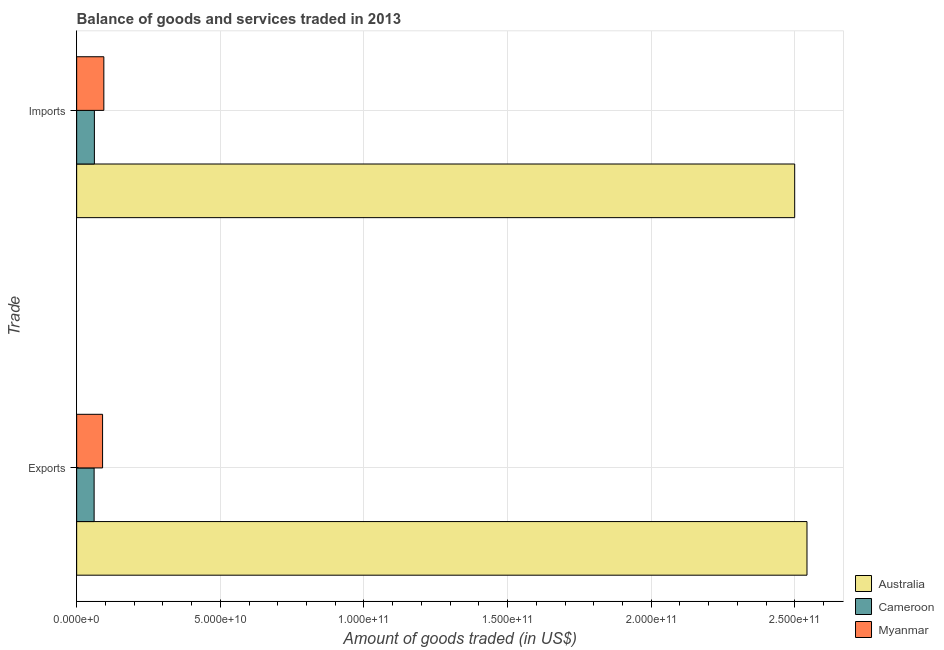How many different coloured bars are there?
Make the answer very short. 3. Are the number of bars per tick equal to the number of legend labels?
Offer a very short reply. Yes. How many bars are there on the 1st tick from the top?
Offer a terse response. 3. How many bars are there on the 2nd tick from the bottom?
Offer a terse response. 3. What is the label of the 2nd group of bars from the top?
Your answer should be compact. Exports. What is the amount of goods imported in Australia?
Give a very brief answer. 2.50e+11. Across all countries, what is the maximum amount of goods imported?
Offer a terse response. 2.50e+11. Across all countries, what is the minimum amount of goods exported?
Make the answer very short. 6.08e+09. In which country was the amount of goods exported minimum?
Your answer should be very brief. Cameroon. What is the total amount of goods exported in the graph?
Provide a succinct answer. 2.69e+11. What is the difference between the amount of goods exported in Myanmar and that in Australia?
Provide a succinct answer. -2.45e+11. What is the difference between the amount of goods imported in Australia and the amount of goods exported in Myanmar?
Make the answer very short. 2.41e+11. What is the average amount of goods imported per country?
Make the answer very short. 8.85e+1. What is the difference between the amount of goods exported and amount of goods imported in Myanmar?
Make the answer very short. -4.40e+08. In how many countries, is the amount of goods exported greater than 130000000000 US$?
Ensure brevity in your answer.  1. What is the ratio of the amount of goods exported in Cameroon to that in Australia?
Your answer should be compact. 0.02. In how many countries, is the amount of goods imported greater than the average amount of goods imported taken over all countries?
Give a very brief answer. 1. What does the 1st bar from the top in Exports represents?
Your answer should be compact. Myanmar. How many countries are there in the graph?
Offer a terse response. 3. Are the values on the major ticks of X-axis written in scientific E-notation?
Make the answer very short. Yes. Where does the legend appear in the graph?
Ensure brevity in your answer.  Bottom right. How are the legend labels stacked?
Provide a short and direct response. Vertical. What is the title of the graph?
Your answer should be very brief. Balance of goods and services traded in 2013. Does "Grenada" appear as one of the legend labels in the graph?
Your answer should be compact. No. What is the label or title of the X-axis?
Provide a succinct answer. Amount of goods traded (in US$). What is the label or title of the Y-axis?
Provide a succinct answer. Trade. What is the Amount of goods traded (in US$) of Australia in Exports?
Make the answer very short. 2.54e+11. What is the Amount of goods traded (in US$) of Cameroon in Exports?
Give a very brief answer. 6.08e+09. What is the Amount of goods traded (in US$) in Myanmar in Exports?
Provide a succinct answer. 9.02e+09. What is the Amount of goods traded (in US$) in Australia in Imports?
Provide a succinct answer. 2.50e+11. What is the Amount of goods traded (in US$) of Cameroon in Imports?
Offer a terse response. 6.17e+09. What is the Amount of goods traded (in US$) of Myanmar in Imports?
Offer a terse response. 9.46e+09. Across all Trade, what is the maximum Amount of goods traded (in US$) in Australia?
Offer a very short reply. 2.54e+11. Across all Trade, what is the maximum Amount of goods traded (in US$) in Cameroon?
Your answer should be very brief. 6.17e+09. Across all Trade, what is the maximum Amount of goods traded (in US$) in Myanmar?
Offer a terse response. 9.46e+09. Across all Trade, what is the minimum Amount of goods traded (in US$) in Australia?
Your response must be concise. 2.50e+11. Across all Trade, what is the minimum Amount of goods traded (in US$) of Cameroon?
Your response must be concise. 6.08e+09. Across all Trade, what is the minimum Amount of goods traded (in US$) in Myanmar?
Provide a succinct answer. 9.02e+09. What is the total Amount of goods traded (in US$) of Australia in the graph?
Give a very brief answer. 5.04e+11. What is the total Amount of goods traded (in US$) of Cameroon in the graph?
Provide a short and direct response. 1.23e+1. What is the total Amount of goods traded (in US$) of Myanmar in the graph?
Offer a very short reply. 1.85e+1. What is the difference between the Amount of goods traded (in US$) of Australia in Exports and that in Imports?
Make the answer very short. 4.28e+09. What is the difference between the Amount of goods traded (in US$) in Cameroon in Exports and that in Imports?
Make the answer very short. -9.46e+07. What is the difference between the Amount of goods traded (in US$) of Myanmar in Exports and that in Imports?
Provide a short and direct response. -4.40e+08. What is the difference between the Amount of goods traded (in US$) of Australia in Exports and the Amount of goods traded (in US$) of Cameroon in Imports?
Give a very brief answer. 2.48e+11. What is the difference between the Amount of goods traded (in US$) in Australia in Exports and the Amount of goods traded (in US$) in Myanmar in Imports?
Offer a terse response. 2.45e+11. What is the difference between the Amount of goods traded (in US$) of Cameroon in Exports and the Amount of goods traded (in US$) of Myanmar in Imports?
Provide a short and direct response. -3.38e+09. What is the average Amount of goods traded (in US$) of Australia per Trade?
Give a very brief answer. 2.52e+11. What is the average Amount of goods traded (in US$) in Cameroon per Trade?
Make the answer very short. 6.13e+09. What is the average Amount of goods traded (in US$) in Myanmar per Trade?
Your answer should be very brief. 9.24e+09. What is the difference between the Amount of goods traded (in US$) in Australia and Amount of goods traded (in US$) in Cameroon in Exports?
Keep it short and to the point. 2.48e+11. What is the difference between the Amount of goods traded (in US$) of Australia and Amount of goods traded (in US$) of Myanmar in Exports?
Provide a succinct answer. 2.45e+11. What is the difference between the Amount of goods traded (in US$) in Cameroon and Amount of goods traded (in US$) in Myanmar in Exports?
Provide a succinct answer. -2.94e+09. What is the difference between the Amount of goods traded (in US$) in Australia and Amount of goods traded (in US$) in Cameroon in Imports?
Provide a succinct answer. 2.44e+11. What is the difference between the Amount of goods traded (in US$) in Australia and Amount of goods traded (in US$) in Myanmar in Imports?
Provide a succinct answer. 2.40e+11. What is the difference between the Amount of goods traded (in US$) of Cameroon and Amount of goods traded (in US$) of Myanmar in Imports?
Provide a succinct answer. -3.29e+09. What is the ratio of the Amount of goods traded (in US$) of Australia in Exports to that in Imports?
Your response must be concise. 1.02. What is the ratio of the Amount of goods traded (in US$) of Cameroon in Exports to that in Imports?
Offer a very short reply. 0.98. What is the ratio of the Amount of goods traded (in US$) in Myanmar in Exports to that in Imports?
Your answer should be very brief. 0.95. What is the difference between the highest and the second highest Amount of goods traded (in US$) in Australia?
Provide a short and direct response. 4.28e+09. What is the difference between the highest and the second highest Amount of goods traded (in US$) in Cameroon?
Keep it short and to the point. 9.46e+07. What is the difference between the highest and the second highest Amount of goods traded (in US$) of Myanmar?
Offer a very short reply. 4.40e+08. What is the difference between the highest and the lowest Amount of goods traded (in US$) in Australia?
Make the answer very short. 4.28e+09. What is the difference between the highest and the lowest Amount of goods traded (in US$) in Cameroon?
Provide a succinct answer. 9.46e+07. What is the difference between the highest and the lowest Amount of goods traded (in US$) of Myanmar?
Ensure brevity in your answer.  4.40e+08. 